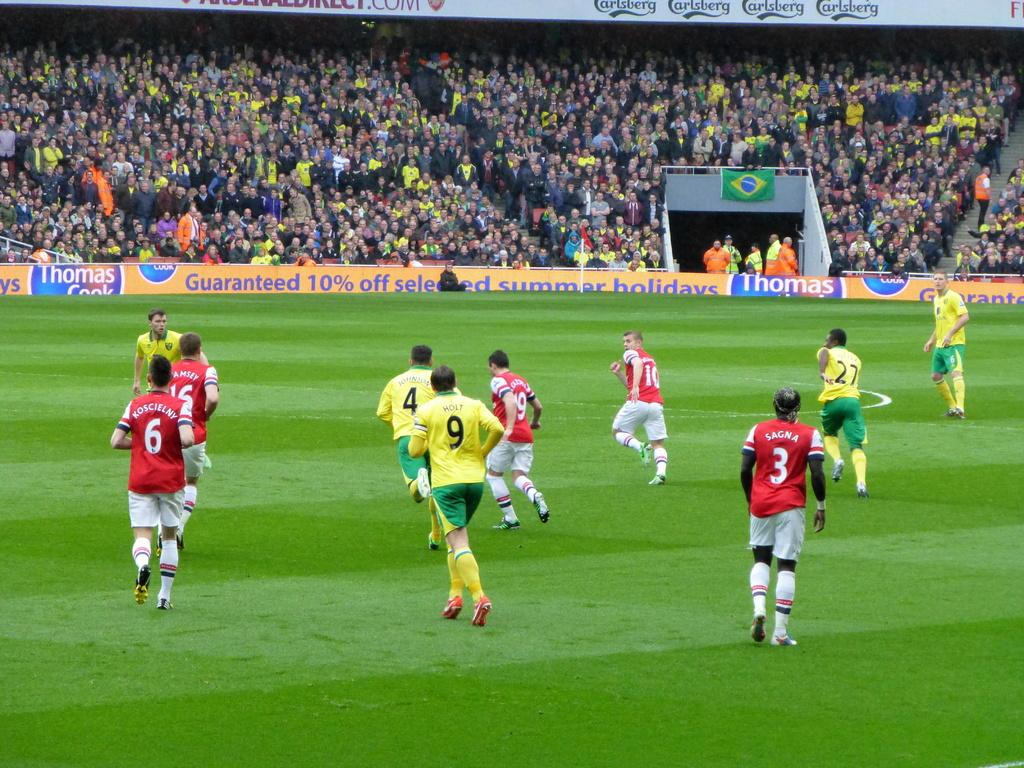<image>
Render a clear and concise summary of the photo. Soccer player are running on a filed and number 9 is wearing a yellow jersey. 